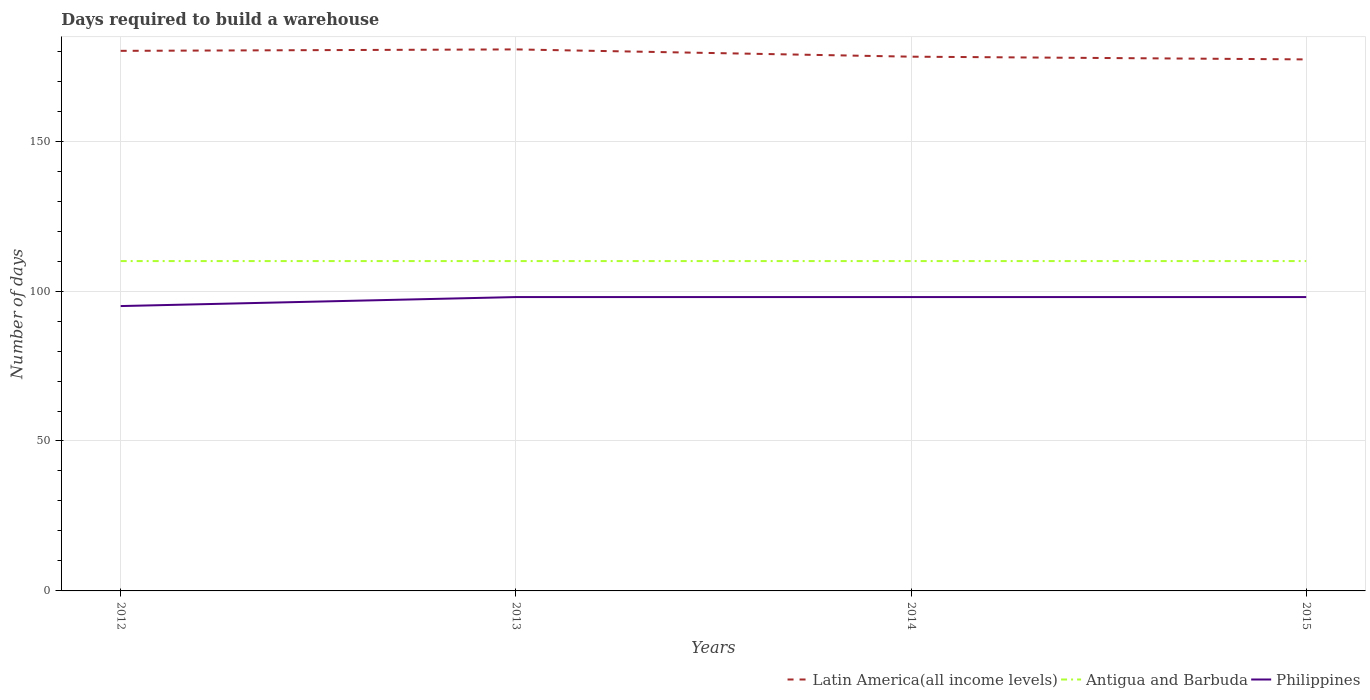How many different coloured lines are there?
Ensure brevity in your answer.  3. Does the line corresponding to Latin America(all income levels) intersect with the line corresponding to Antigua and Barbuda?
Your answer should be very brief. No. Is the number of lines equal to the number of legend labels?
Offer a very short reply. Yes. Across all years, what is the maximum days required to build a warehouse in in Antigua and Barbuda?
Your answer should be compact. 110. In which year was the days required to build a warehouse in in Antigua and Barbuda maximum?
Your answer should be compact. 2012. What is the total days required to build a warehouse in in Latin America(all income levels) in the graph?
Your answer should be compact. -0.48. What is the difference between the highest and the second highest days required to build a warehouse in in Antigua and Barbuda?
Provide a short and direct response. 0. How many years are there in the graph?
Provide a short and direct response. 4. What is the difference between two consecutive major ticks on the Y-axis?
Your response must be concise. 50. How many legend labels are there?
Provide a succinct answer. 3. How are the legend labels stacked?
Keep it short and to the point. Horizontal. What is the title of the graph?
Offer a very short reply. Days required to build a warehouse. Does "Rwanda" appear as one of the legend labels in the graph?
Your answer should be compact. No. What is the label or title of the X-axis?
Make the answer very short. Years. What is the label or title of the Y-axis?
Keep it short and to the point. Number of days. What is the Number of days in Latin America(all income levels) in 2012?
Ensure brevity in your answer.  180.11. What is the Number of days of Antigua and Barbuda in 2012?
Keep it short and to the point. 110. What is the Number of days of Latin America(all income levels) in 2013?
Offer a terse response. 180.59. What is the Number of days in Antigua and Barbuda in 2013?
Your answer should be very brief. 110. What is the Number of days of Philippines in 2013?
Provide a succinct answer. 98. What is the Number of days of Latin America(all income levels) in 2014?
Ensure brevity in your answer.  178.17. What is the Number of days of Antigua and Barbuda in 2014?
Offer a very short reply. 110. What is the Number of days in Latin America(all income levels) in 2015?
Offer a terse response. 177.26. What is the Number of days in Antigua and Barbuda in 2015?
Ensure brevity in your answer.  110. What is the Number of days in Philippines in 2015?
Keep it short and to the point. 98. Across all years, what is the maximum Number of days of Latin America(all income levels)?
Keep it short and to the point. 180.59. Across all years, what is the maximum Number of days in Antigua and Barbuda?
Provide a succinct answer. 110. Across all years, what is the maximum Number of days in Philippines?
Your response must be concise. 98. Across all years, what is the minimum Number of days of Latin America(all income levels)?
Your answer should be compact. 177.26. Across all years, what is the minimum Number of days of Antigua and Barbuda?
Offer a very short reply. 110. What is the total Number of days in Latin America(all income levels) in the graph?
Make the answer very short. 716.14. What is the total Number of days in Antigua and Barbuda in the graph?
Give a very brief answer. 440. What is the total Number of days of Philippines in the graph?
Ensure brevity in your answer.  389. What is the difference between the Number of days of Latin America(all income levels) in 2012 and that in 2013?
Keep it short and to the point. -0.48. What is the difference between the Number of days in Philippines in 2012 and that in 2013?
Offer a very short reply. -3. What is the difference between the Number of days of Latin America(all income levels) in 2012 and that in 2014?
Offer a terse response. 1.94. What is the difference between the Number of days in Antigua and Barbuda in 2012 and that in 2014?
Offer a very short reply. 0. What is the difference between the Number of days in Philippines in 2012 and that in 2014?
Keep it short and to the point. -3. What is the difference between the Number of days in Latin America(all income levels) in 2012 and that in 2015?
Ensure brevity in your answer.  2.85. What is the difference between the Number of days in Antigua and Barbuda in 2012 and that in 2015?
Provide a short and direct response. 0. What is the difference between the Number of days of Latin America(all income levels) in 2013 and that in 2014?
Provide a succinct answer. 2.42. What is the difference between the Number of days of Antigua and Barbuda in 2013 and that in 2014?
Provide a succinct answer. 0. What is the difference between the Number of days in Philippines in 2013 and that in 2014?
Your answer should be compact. 0. What is the difference between the Number of days in Antigua and Barbuda in 2013 and that in 2015?
Give a very brief answer. 0. What is the difference between the Number of days of Latin America(all income levels) in 2014 and that in 2015?
Offer a very short reply. 0.91. What is the difference between the Number of days of Latin America(all income levels) in 2012 and the Number of days of Antigua and Barbuda in 2013?
Offer a very short reply. 70.11. What is the difference between the Number of days in Latin America(all income levels) in 2012 and the Number of days in Philippines in 2013?
Offer a terse response. 82.11. What is the difference between the Number of days of Latin America(all income levels) in 2012 and the Number of days of Antigua and Barbuda in 2014?
Your answer should be compact. 70.11. What is the difference between the Number of days of Latin America(all income levels) in 2012 and the Number of days of Philippines in 2014?
Make the answer very short. 82.11. What is the difference between the Number of days in Latin America(all income levels) in 2012 and the Number of days in Antigua and Barbuda in 2015?
Provide a succinct answer. 70.11. What is the difference between the Number of days in Latin America(all income levels) in 2012 and the Number of days in Philippines in 2015?
Provide a short and direct response. 82.11. What is the difference between the Number of days of Latin America(all income levels) in 2013 and the Number of days of Antigua and Barbuda in 2014?
Provide a succinct answer. 70.59. What is the difference between the Number of days in Latin America(all income levels) in 2013 and the Number of days in Philippines in 2014?
Ensure brevity in your answer.  82.59. What is the difference between the Number of days of Latin America(all income levels) in 2013 and the Number of days of Antigua and Barbuda in 2015?
Give a very brief answer. 70.59. What is the difference between the Number of days in Latin America(all income levels) in 2013 and the Number of days in Philippines in 2015?
Your answer should be compact. 82.59. What is the difference between the Number of days in Latin America(all income levels) in 2014 and the Number of days in Antigua and Barbuda in 2015?
Provide a succinct answer. 68.17. What is the difference between the Number of days in Latin America(all income levels) in 2014 and the Number of days in Philippines in 2015?
Give a very brief answer. 80.17. What is the average Number of days of Latin America(all income levels) per year?
Ensure brevity in your answer.  179.03. What is the average Number of days in Antigua and Barbuda per year?
Give a very brief answer. 110. What is the average Number of days in Philippines per year?
Your response must be concise. 97.25. In the year 2012, what is the difference between the Number of days in Latin America(all income levels) and Number of days in Antigua and Barbuda?
Offer a terse response. 70.11. In the year 2012, what is the difference between the Number of days in Latin America(all income levels) and Number of days in Philippines?
Give a very brief answer. 85.11. In the year 2013, what is the difference between the Number of days in Latin America(all income levels) and Number of days in Antigua and Barbuda?
Offer a terse response. 70.59. In the year 2013, what is the difference between the Number of days in Latin America(all income levels) and Number of days in Philippines?
Provide a short and direct response. 82.59. In the year 2014, what is the difference between the Number of days of Latin America(all income levels) and Number of days of Antigua and Barbuda?
Your answer should be compact. 68.17. In the year 2014, what is the difference between the Number of days in Latin America(all income levels) and Number of days in Philippines?
Provide a succinct answer. 80.17. In the year 2015, what is the difference between the Number of days of Latin America(all income levels) and Number of days of Antigua and Barbuda?
Ensure brevity in your answer.  67.26. In the year 2015, what is the difference between the Number of days of Latin America(all income levels) and Number of days of Philippines?
Make the answer very short. 79.26. What is the ratio of the Number of days in Latin America(all income levels) in 2012 to that in 2013?
Your response must be concise. 1. What is the ratio of the Number of days of Antigua and Barbuda in 2012 to that in 2013?
Provide a succinct answer. 1. What is the ratio of the Number of days in Philippines in 2012 to that in 2013?
Offer a terse response. 0.97. What is the ratio of the Number of days in Latin America(all income levels) in 2012 to that in 2014?
Your answer should be compact. 1.01. What is the ratio of the Number of days in Philippines in 2012 to that in 2014?
Provide a succinct answer. 0.97. What is the ratio of the Number of days of Latin America(all income levels) in 2012 to that in 2015?
Your response must be concise. 1.02. What is the ratio of the Number of days in Antigua and Barbuda in 2012 to that in 2015?
Offer a terse response. 1. What is the ratio of the Number of days of Philippines in 2012 to that in 2015?
Offer a very short reply. 0.97. What is the ratio of the Number of days in Latin America(all income levels) in 2013 to that in 2014?
Make the answer very short. 1.01. What is the ratio of the Number of days in Antigua and Barbuda in 2013 to that in 2014?
Make the answer very short. 1. What is the ratio of the Number of days in Philippines in 2013 to that in 2014?
Your answer should be very brief. 1. What is the ratio of the Number of days in Latin America(all income levels) in 2013 to that in 2015?
Offer a terse response. 1.02. What is the ratio of the Number of days of Antigua and Barbuda in 2013 to that in 2015?
Keep it short and to the point. 1. What is the ratio of the Number of days of Philippines in 2013 to that in 2015?
Ensure brevity in your answer.  1. What is the ratio of the Number of days in Latin America(all income levels) in 2014 to that in 2015?
Offer a very short reply. 1.01. What is the difference between the highest and the second highest Number of days in Latin America(all income levels)?
Your answer should be very brief. 0.48. What is the difference between the highest and the second highest Number of days in Antigua and Barbuda?
Offer a terse response. 0. What is the difference between the highest and the lowest Number of days of Latin America(all income levels)?
Make the answer very short. 3.33. 